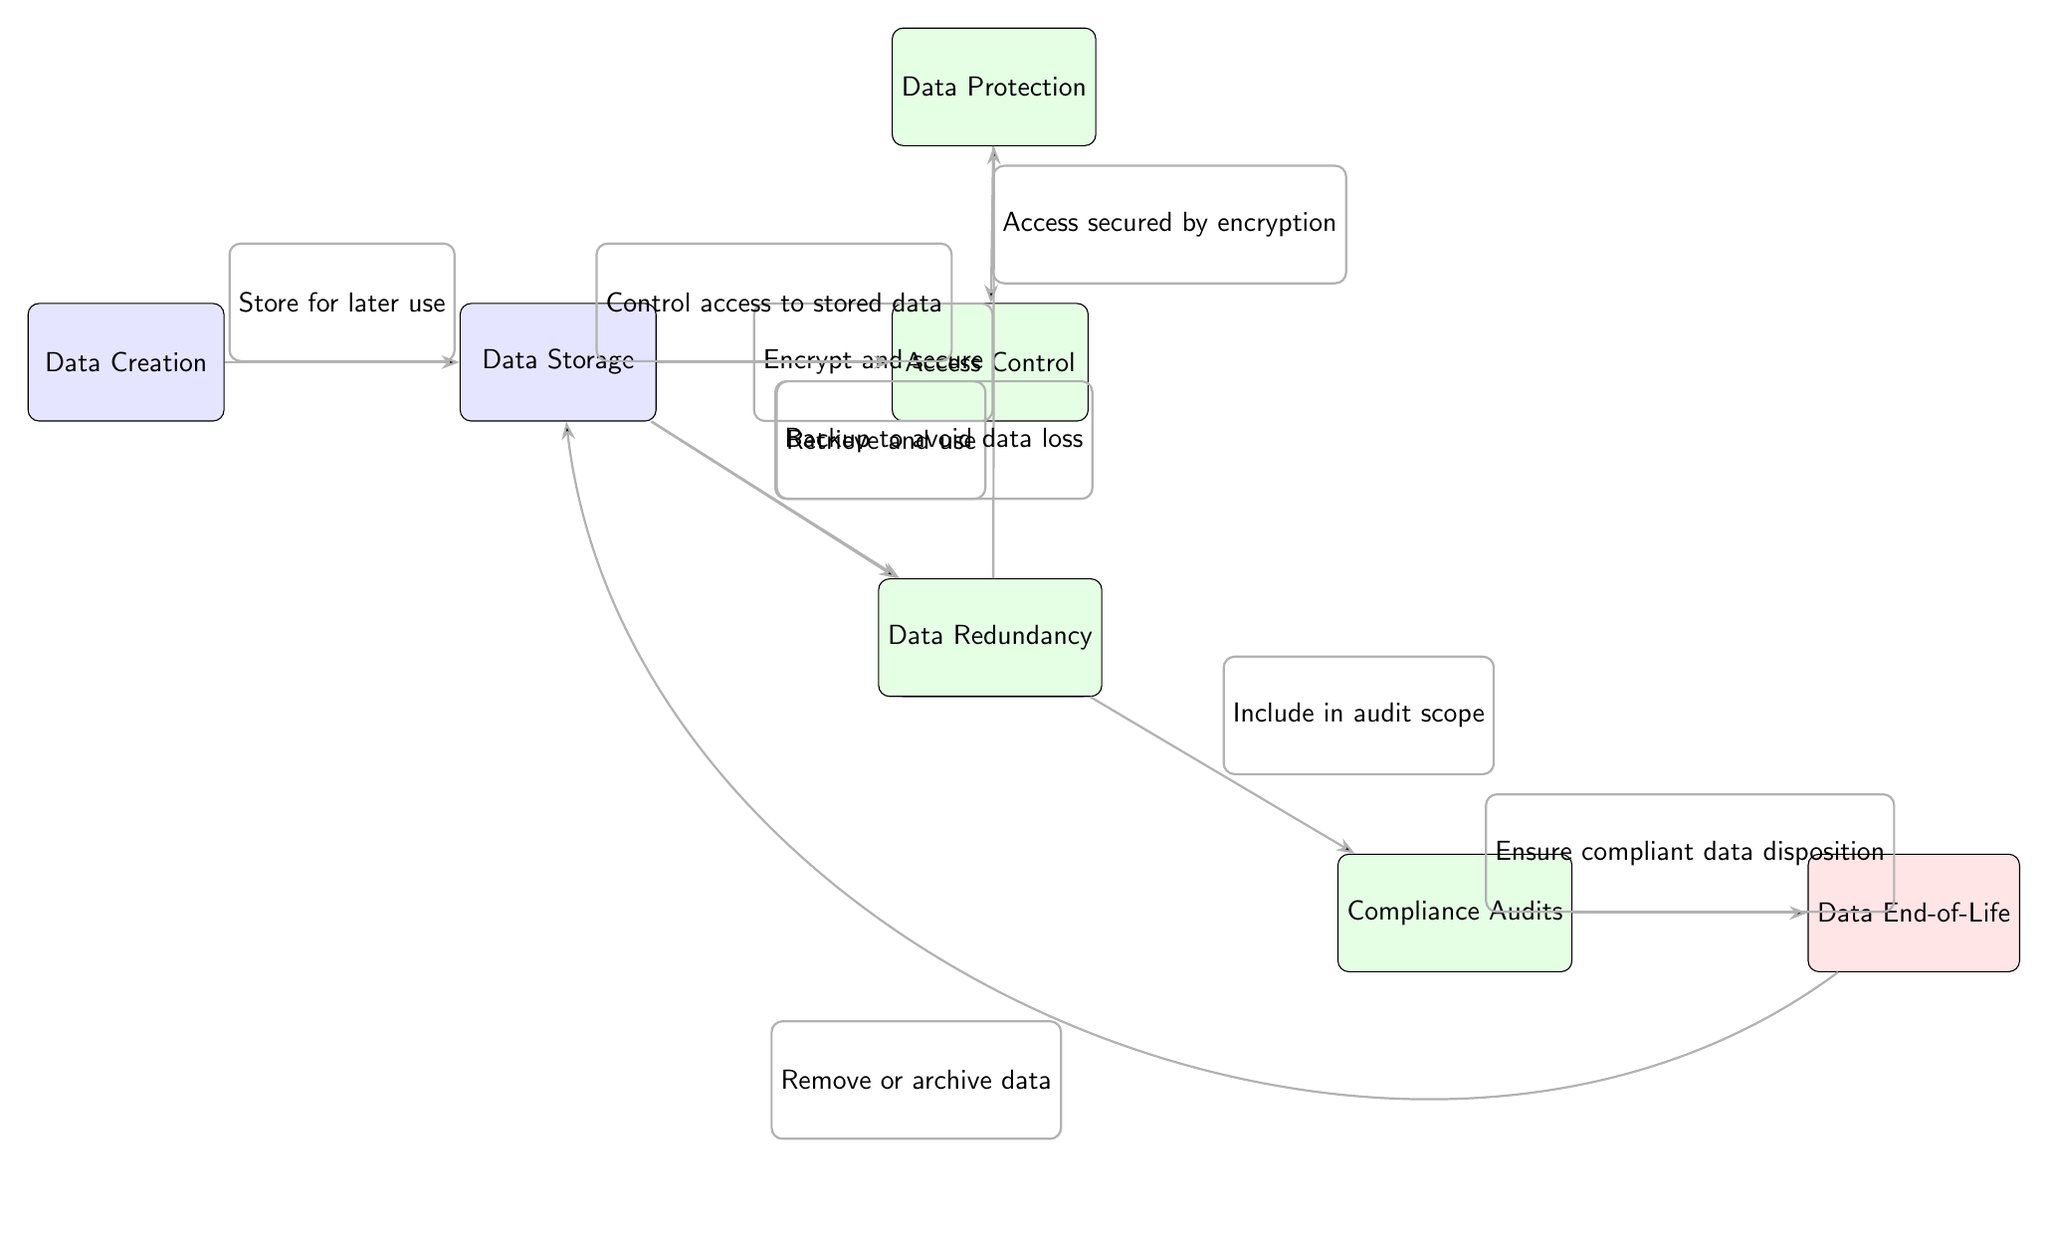What is the first step in the data lifecycle? The first step indicated in the diagram is "Data Creation," shown as the initial node on the left.
Answer: Data Creation How many security compliance measures are displayed in the diagram? The diagram includes four security compliance measures: Data Protection, Access Control, Data Redundancy, and Compliance Audits.
Answer: Four Which node is associated with compressing data? The diagram does not explicitly mention data compression; however, nodes related to protecting and controlling access to the data imply that security measures may involve compression as an element of data protection.
Answer: None What process follows data storage? According to the diagram, the process that follows data storage is "Data Utilization," linked directly to the storage node with the action "Retrieve and use."
Answer: Data Utilization What is the final step in the data lifecycle? The last step in the data lifecycle is "Data End-of-Life," which is the endpoint of the flow indicated by the end node on the right side of the diagram.
Answer: Data End-of-Life Which nodes are linked by the action "Include in audit scope"? The action "Include in audit scope" connects the nodes "Data Redundancy" and "Compliance Audits," indicating that redundancy must be included in the audit process.
Answer: Data Redundancy and Compliance Audits How does data protection relate to access control? Data Protection and Access Control are connected through the action "Access secured by encryption," indicating that encryption in data protection impacts how access is controlled.
Answer: Access secured by encryption Which node indicates the action for fault tolerance in the diagram? The node that indicates an action for fault tolerance in the diagram is "Data Redundancy," as it addresses the necessity to back up data to prevent loss.
Answer: Data Redundancy 